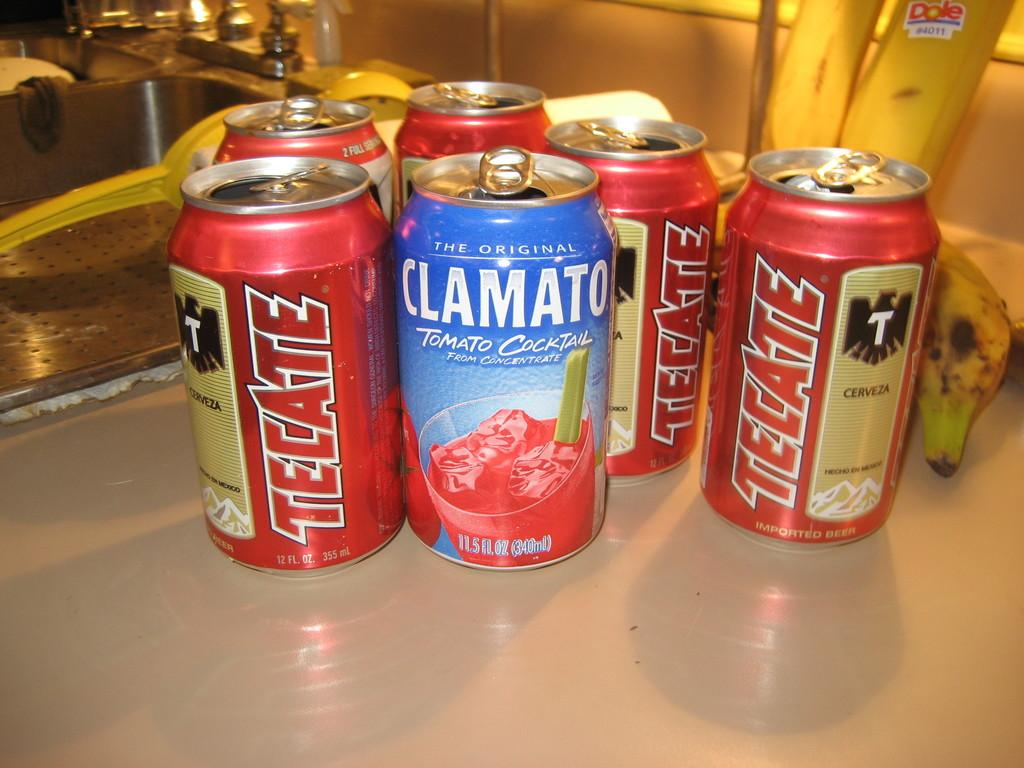<image>
Relay a brief, clear account of the picture shown. Several beverage cans are on a counter with a Dole banana in the background. 